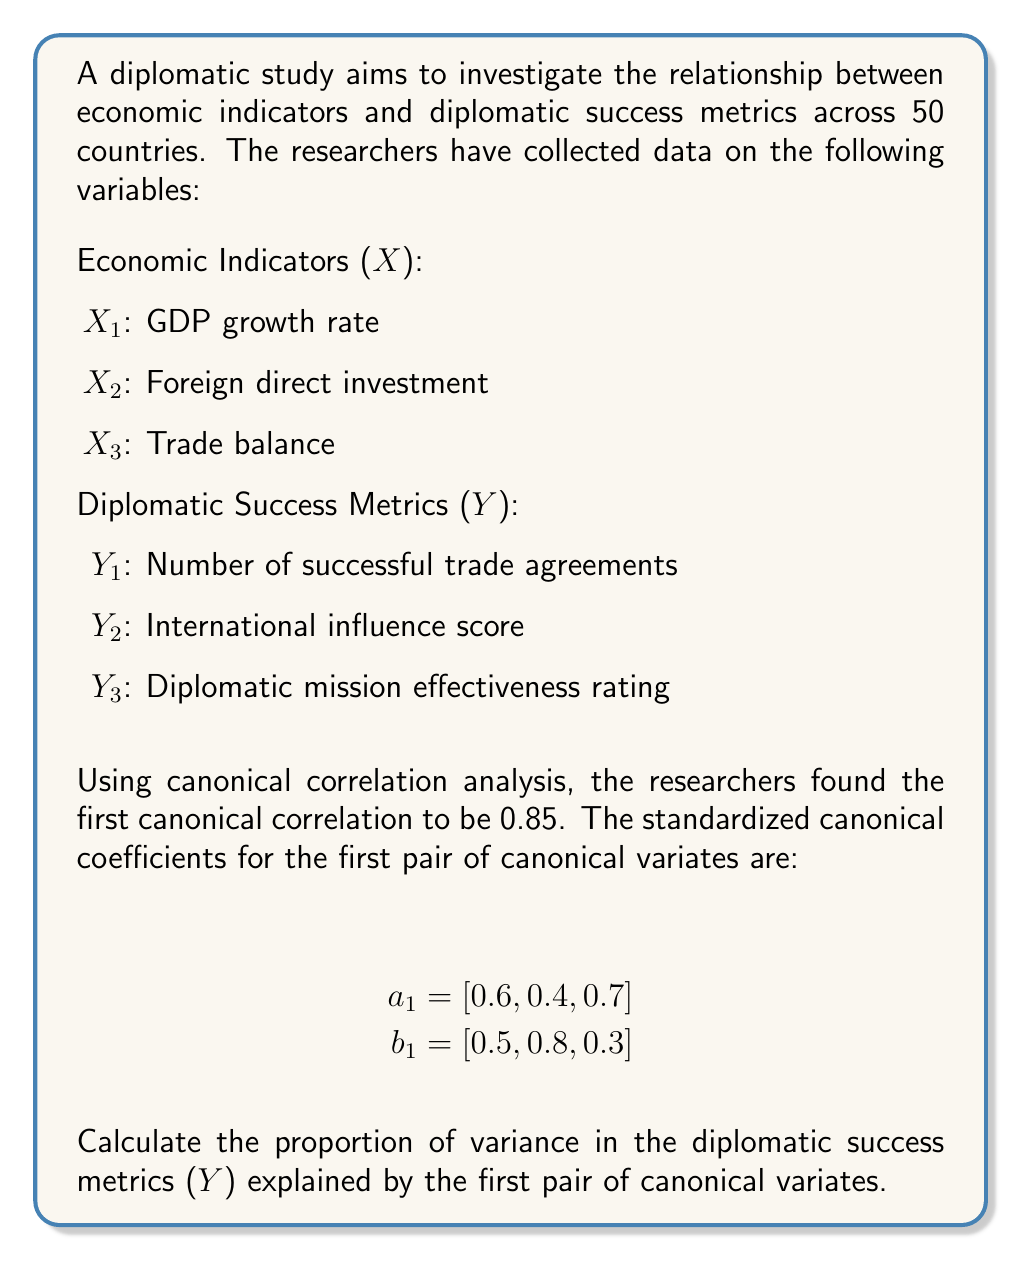Show me your answer to this math problem. To solve this problem, we need to follow these steps:

1) Recall that the proportion of variance explained by the first pair of canonical variates for the Y variables is given by:

   $$\frac{\sum_{i=1}^{q} b_{1i}^2}{q} \cdot r_c^2$$

   Where:
   - $b_{1i}$ are the standardized canonical coefficients for Y
   - $q$ is the number of Y variables
   - $r_c$ is the canonical correlation

2) We have:
   - $b_1 = [0.5, 0.8, 0.3]$
   - $q = 3$ (number of Y variables)
   - $r_c = 0.85$ (given canonical correlation)

3) Calculate the sum of squared coefficients:

   $$\sum_{i=1}^{q} b_{1i}^2 = 0.5^2 + 0.8^2 + 0.3^2 = 0.25 + 0.64 + 0.09 = 0.98$$

4) Now we can calculate the proportion of variance:

   $$\frac{0.98}{3} \cdot 0.85^2 = 0.326667 \cdot 0.7225 = 0.236$$

5) Convert to percentage:

   $0.236 \cdot 100\% = 23.6\%$

Therefore, the first pair of canonical variates explains 23.6% of the variance in the diplomatic success metrics (Y).
Answer: 23.6% 